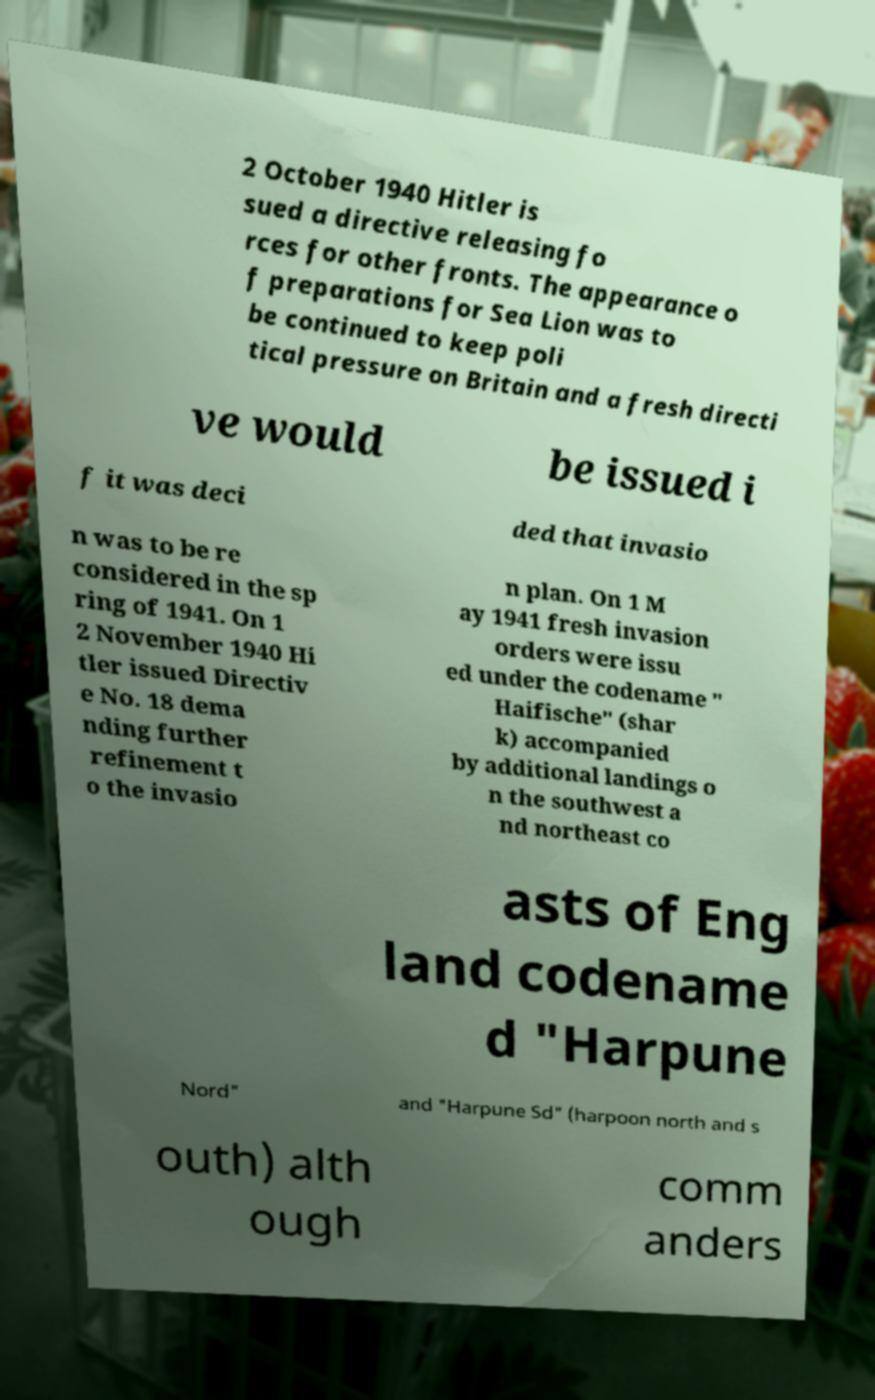Can you accurately transcribe the text from the provided image for me? 2 October 1940 Hitler is sued a directive releasing fo rces for other fronts. The appearance o f preparations for Sea Lion was to be continued to keep poli tical pressure on Britain and a fresh directi ve would be issued i f it was deci ded that invasio n was to be re considered in the sp ring of 1941. On 1 2 November 1940 Hi tler issued Directiv e No. 18 dema nding further refinement t o the invasio n plan. On 1 M ay 1941 fresh invasion orders were issu ed under the codename " Haifische" (shar k) accompanied by additional landings o n the southwest a nd northeast co asts of Eng land codename d "Harpune Nord" and "Harpune Sd" (harpoon north and s outh) alth ough comm anders 